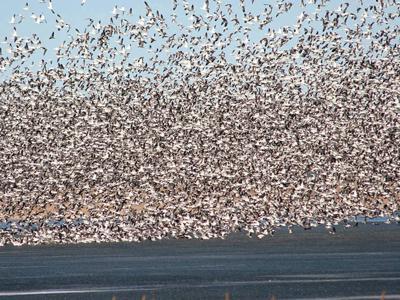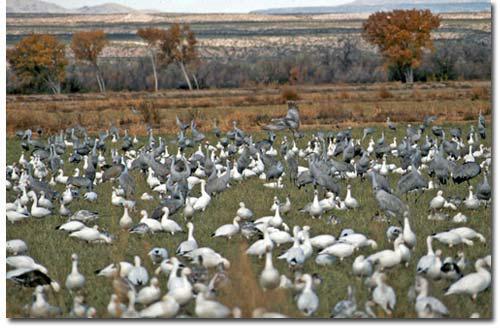The first image is the image on the left, the second image is the image on the right. Assess this claim about the two images: "There are less than five birds in one of the pictures.". Correct or not? Answer yes or no. No. The first image is the image on the left, the second image is the image on the right. For the images displayed, is the sentence "An image contains no more than five fowl." factually correct? Answer yes or no. No. 